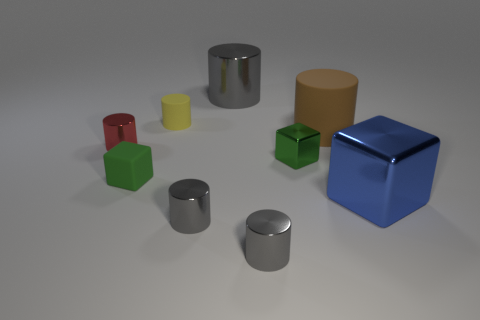There is a large metal thing that is to the right of the gray metal cylinder that is to the right of the gray shiny object behind the brown rubber object; what is its shape?
Provide a short and direct response. Cube. Is the size of the shiny cube that is left of the blue cube the same as the green matte thing?
Your answer should be compact. Yes. What shape is the large object that is behind the red cylinder and right of the big gray thing?
Your answer should be very brief. Cylinder. Do the large cube and the tiny rubber block in front of the small matte cylinder have the same color?
Your answer should be compact. No. There is a rubber cylinder that is in front of the matte cylinder left of the large object that is on the left side of the large matte cylinder; what color is it?
Offer a terse response. Brown. There is a matte object that is the same shape as the blue metal object; what is its color?
Give a very brief answer. Green. Are there an equal number of gray objects behind the brown thing and green matte objects?
Make the answer very short. Yes. How many balls are gray metal things or rubber things?
Your answer should be very brief. 0. What color is the block that is made of the same material as the yellow thing?
Your answer should be compact. Green. Are the big brown object and the tiny gray object that is right of the large gray thing made of the same material?
Your answer should be compact. No. 